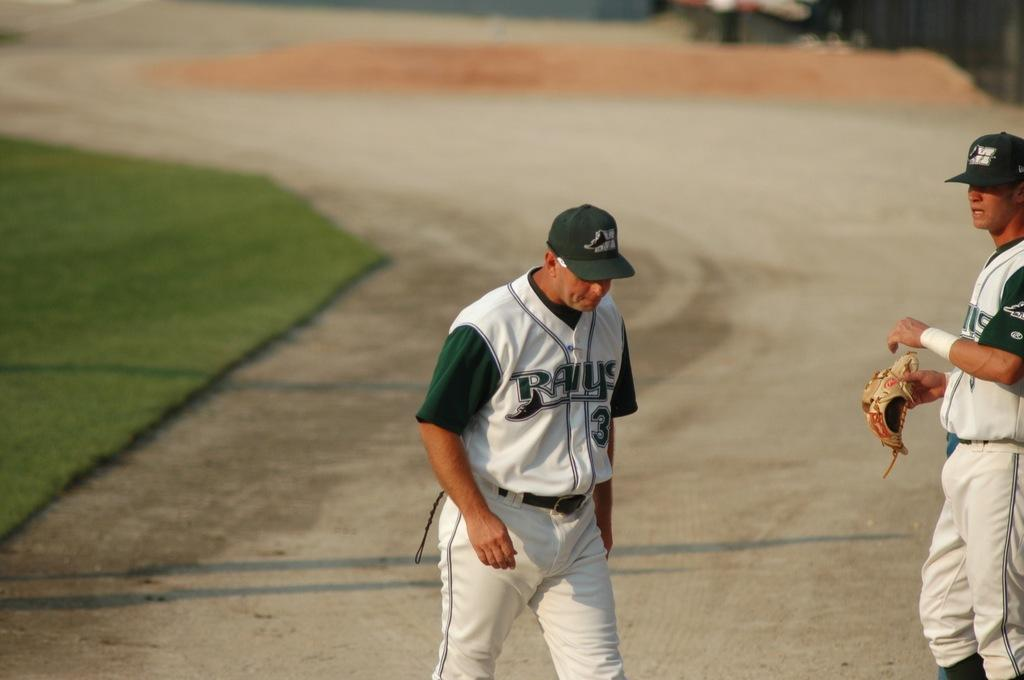<image>
Create a compact narrative representing the image presented. Number 3 of the Rays walks on the dirt track. 